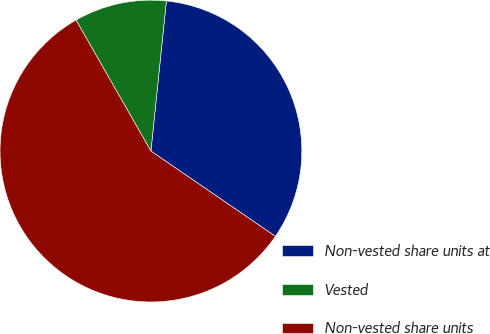Convert chart. <chart><loc_0><loc_0><loc_500><loc_500><pie_chart><fcel>Non-vested share units at<fcel>Vested<fcel>Non-vested share units<nl><fcel>32.93%<fcel>9.9%<fcel>57.18%<nl></chart> 